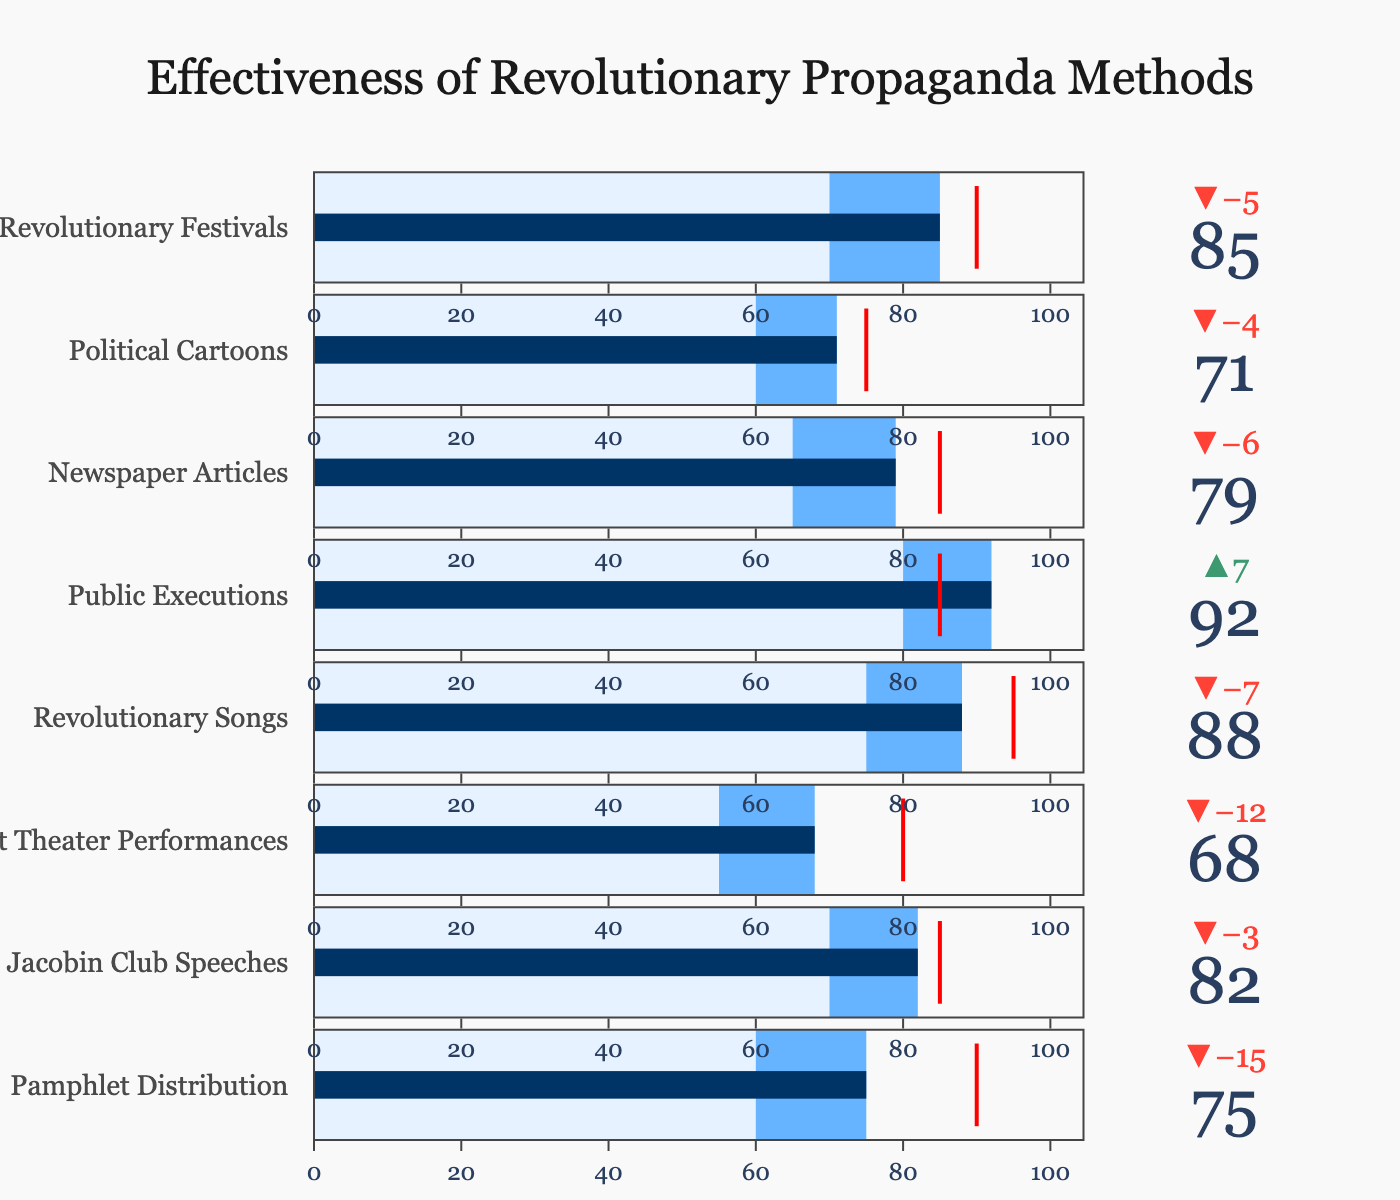What is the title of the figure? The title is displayed at the top center of the figure. It is crucial for understanding what the figure represents.
Answer: Effectiveness of Revolutionary Propaganda Methods How many categories of propaganda methods are evaluated in the figure? By counting the number of categories listed along the vertical axis of the figure, you can determine the total number of evaluated methods.
Answer: 8 Which propaganda method has the highest actual effectiveness according to the figure? Look for the category with the highest "Actual" value indicated by the bar in the figure.
Answer: Public Executions Which propaganda method fell short the most compared to its target? Identify the category with the largest negative delta between the "Actual" and "Target" values.
Answer: Pamphlet Distribution What is the effectiveness of Revolutionary Songs compared to its target? Look at the "Actual" and "Target" values for Revolutionary Songs and compare them directly.
Answer: 88 out of 95 Which propaganda method performed better than its target? Check the categories where the "Actual" value surpasses the "Target" value.
Answer: Public Executions What is the difference in actual effectiveness between Newspaper Articles and Political Cartoons? Subtract the "Actual" value of Political Cartoons from the "Actual" value of Newspaper Articles.
Answer: 79 - 71 = 8 How does the effectiveness of Street Theater Performances compare to the Comparative value? Locate the "Actual" and "Comparative" values for Street Theater Performances and compare them.
Answer: 68 vs. 55 Calculate the average effectiveness of all propaganda methods based on the "Actual" values. Sum all "Actual" values and divide by the number of categories (8). The sum is 75+82+68+88+92+79+71+85 = 640, so the average is 640 / 8.
Answer: 80 Which two propaganda methods have the closest actual effectiveness values? Compare the "Actual" values of all categories and identify the pair with the smallest difference.
Answer: Jacobin Club Speeches and Newspaper Articles (82 and 79) 